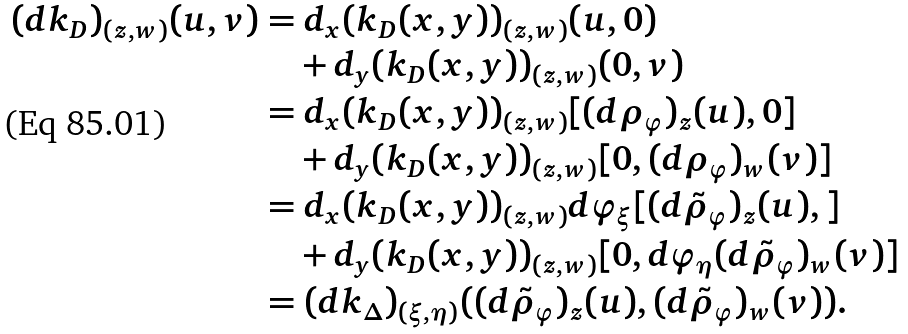<formula> <loc_0><loc_0><loc_500><loc_500>( d k _ { D } ) _ { ( z , w ) } ( u , v ) & = d _ { x } ( k _ { D } ( x , y ) ) _ { ( z , w ) } ( u , 0 ) \\ & \quad + d _ { y } ( k _ { D } ( x , y ) ) _ { ( z , w ) } ( 0 , v ) \\ & = d _ { x } ( k _ { D } ( x , y ) ) _ { ( z , w ) } [ ( d \rho _ { \varphi } ) _ { z } ( u ) , 0 ] \\ & \quad + d _ { y } ( k _ { D } ( x , y ) ) _ { ( z , w ) } [ 0 , ( d \rho _ { \varphi } ) _ { w } ( v ) ] \\ & = d _ { x } ( k _ { D } ( x , y ) ) _ { ( z , w ) } d \varphi _ { \xi } [ ( d \tilde { \rho } _ { \varphi } ) _ { z } ( u ) , ] \\ & \quad + d _ { y } ( k _ { D } ( x , y ) ) _ { ( z , w ) } [ 0 , d \varphi _ { \eta } ( d \tilde { \rho } _ { \varphi } ) _ { w } ( v ) ] \\ & = ( d k _ { \Delta } ) _ { ( \xi , \eta ) } ( ( d \tilde { \rho } _ { \varphi } ) _ { z } ( u ) , ( d \tilde { \rho } _ { \varphi } ) _ { w } ( v ) ) .</formula> 